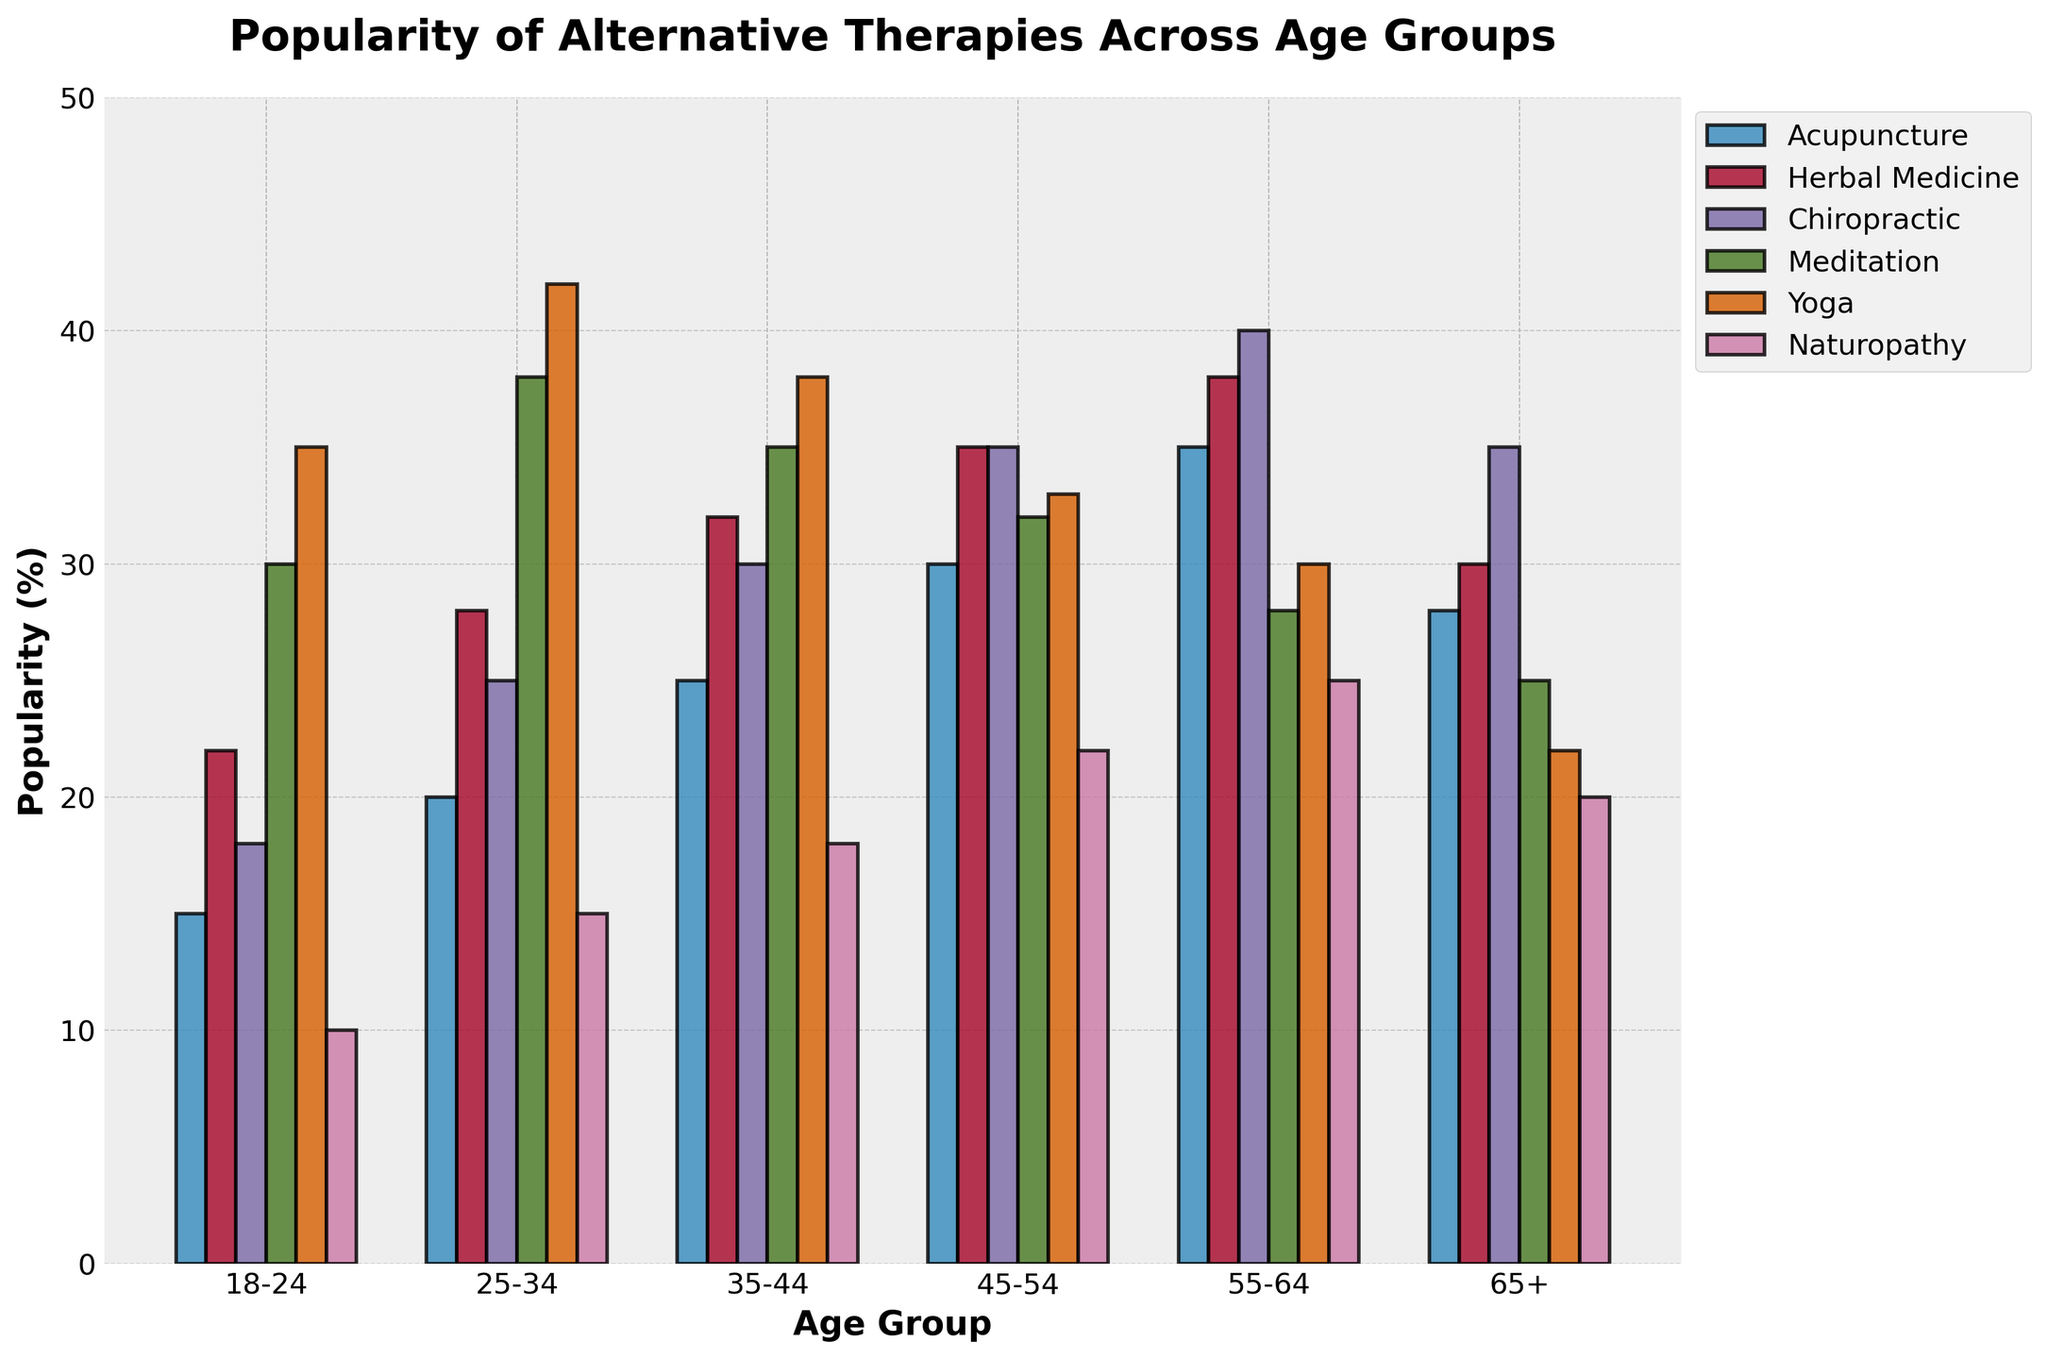Which age group has the highest popularity for Yoga? Look at the height of the bars for Yoga across different age groups. The bar for the 25-34 age group is the tallest.
Answer: 25-34 What's the difference in popularity between Acupuncture and Herbal Medicine for the 45-54 age group? For the 45-54 age group, Acupuncture has a value of 30 and Herbal Medicine has a value of 35. The difference is 35 - 30.
Answer: 5 Which therapy is the least popular among the 18-24 age group? Compare the height of all bars for the 18-24 age group. Naturopathy has the shortest bar at 10.
Answer: Naturopathy What is the average popularity of Meditation across all age groups? Sum up the Meditation values (30, 38, 35, 32, 28, 25) and divide by the number of age groups (6). The sum is 188, and the average is 188/6.
Answer: 31.3 Compare the popularity of Chiropractic for the 35-44 and 55-64 age groups. Which one is higher? The value for Chiropractic in the 35-44 age group is 30, while for the 55-64 age group it is 40. 40 is greater than 30.
Answer: 55-64 How many age groups have a higher popularity for Herbal Medicine than Acupuncture? Compare the values of Herbal Medicine and Acupuncture for each age group. 18-24, 25-34, 35-44, and 45-54 age groups have higher values for Herbal Medicine.
Answer: 4 Which therapy shows a decline in popularity as the age groups increase? Look for a therapy where the bar heights generally decrease from younger to older age groups. Yoga decreases steadily from 18-24 to 65+.
Answer: Yoga Is the popularity of Naturopathy higher in the 25-34 or 65+ age group? Naturopathy has a value of 15 for the 25-34 age group and 20 for the 65+ age group. 20 is greater than 15.
Answer: 65+ What is the total popularity for Acupuncture across all age groups? Sum the values of Acupuncture (15, 20, 25, 30, 35, 28). The total is 15 + 20 + 25 + 30 + 35 + 28.
Answer: 153 Which age group has the lowest popularity for Meditation, and what is the value? Look at the heights of the Meditation bars. The 65+ age group has the lowest bar with a value of 25.
Answer: 65+, 25 